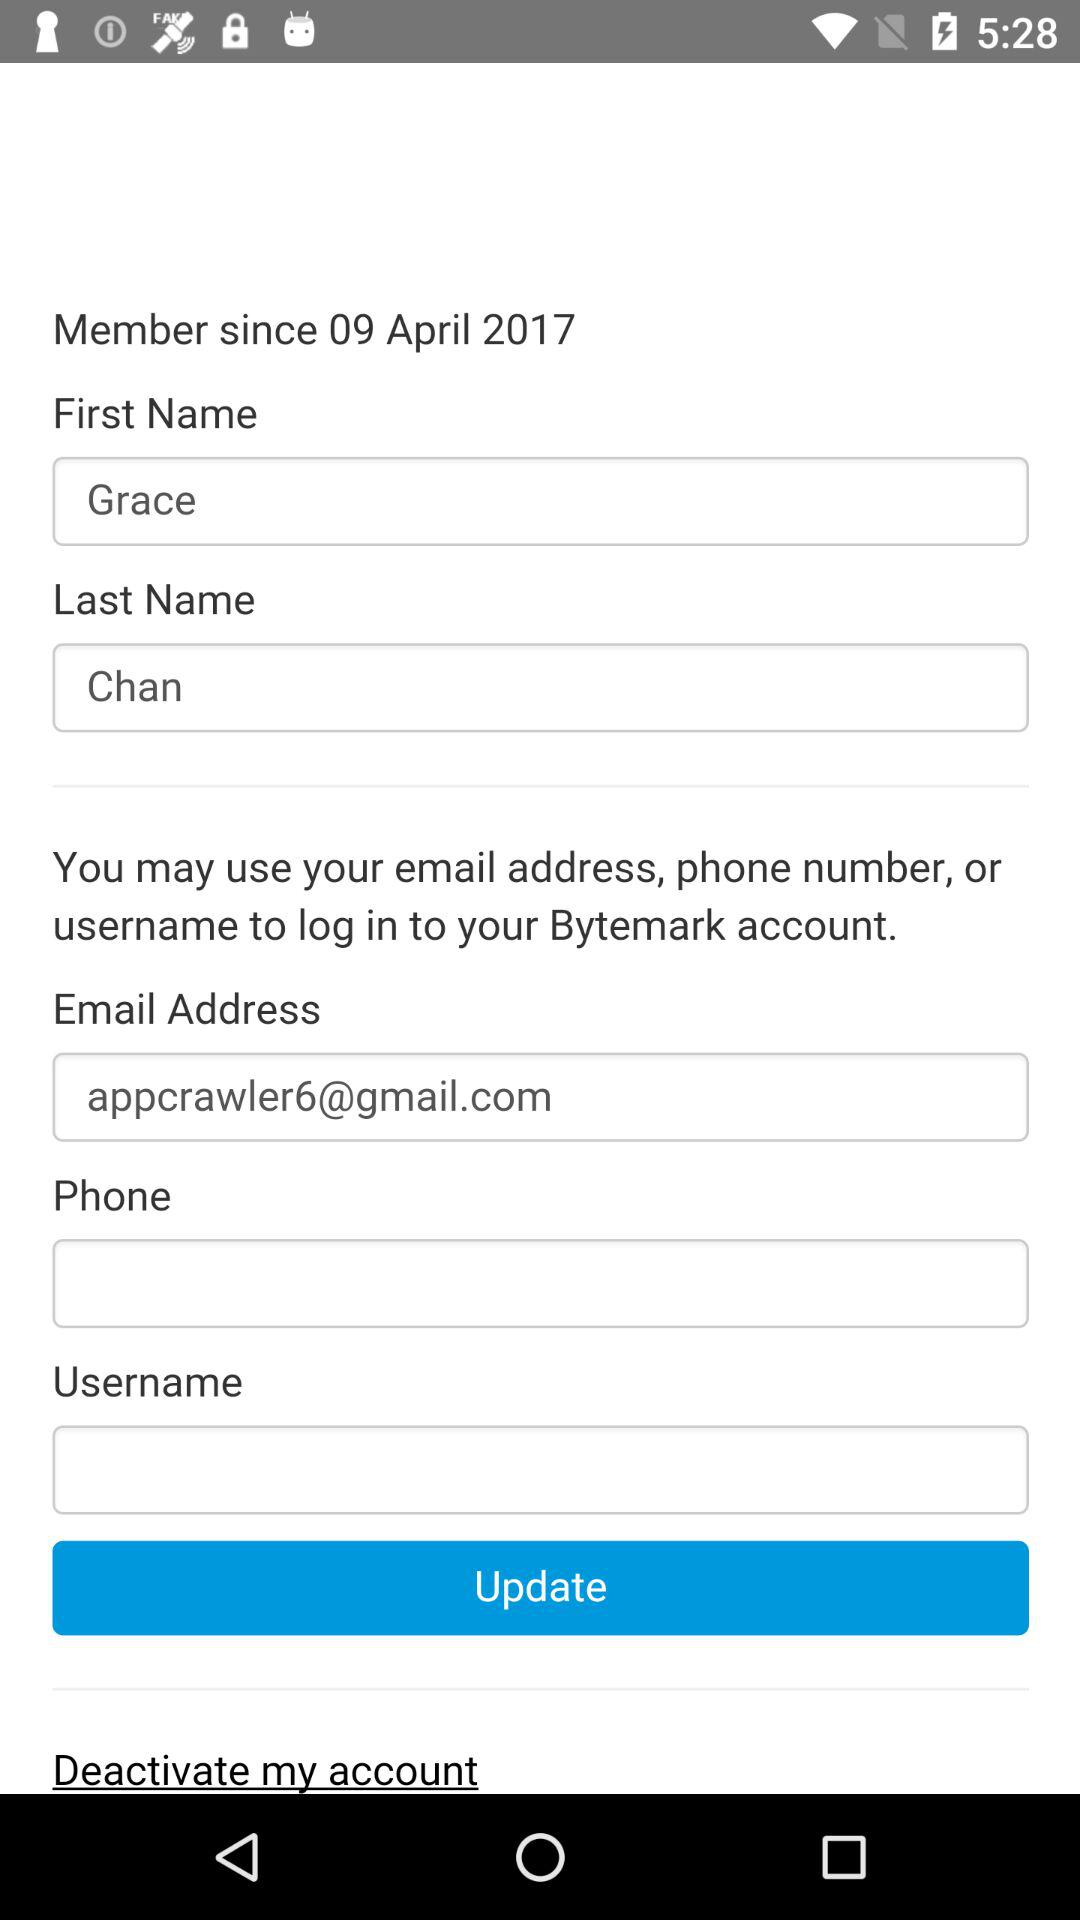What is the first name of the user? The first name of the user is Grace. 